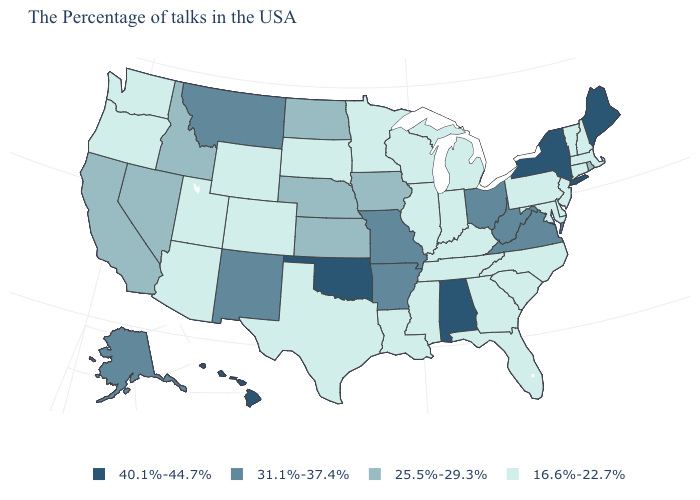Name the states that have a value in the range 16.6%-22.7%?
Keep it brief. Massachusetts, New Hampshire, Vermont, Connecticut, New Jersey, Delaware, Maryland, Pennsylvania, North Carolina, South Carolina, Florida, Georgia, Michigan, Kentucky, Indiana, Tennessee, Wisconsin, Illinois, Mississippi, Louisiana, Minnesota, Texas, South Dakota, Wyoming, Colorado, Utah, Arizona, Washington, Oregon. What is the value of Nevada?
Write a very short answer. 25.5%-29.3%. Which states have the lowest value in the West?
Write a very short answer. Wyoming, Colorado, Utah, Arizona, Washington, Oregon. Name the states that have a value in the range 25.5%-29.3%?
Keep it brief. Rhode Island, Iowa, Kansas, Nebraska, North Dakota, Idaho, Nevada, California. What is the lowest value in the USA?
Keep it brief. 16.6%-22.7%. What is the lowest value in the USA?
Keep it brief. 16.6%-22.7%. Name the states that have a value in the range 25.5%-29.3%?
Short answer required. Rhode Island, Iowa, Kansas, Nebraska, North Dakota, Idaho, Nevada, California. Does Arkansas have a higher value than Hawaii?
Answer briefly. No. What is the highest value in the USA?
Be succinct. 40.1%-44.7%. Among the states that border Oregon , does California have the lowest value?
Give a very brief answer. No. What is the value of Georgia?
Answer briefly. 16.6%-22.7%. Does the map have missing data?
Quick response, please. No. Among the states that border Delaware , which have the lowest value?
Short answer required. New Jersey, Maryland, Pennsylvania. Does Hawaii have the highest value in the West?
Give a very brief answer. Yes. What is the highest value in the USA?
Be succinct. 40.1%-44.7%. 